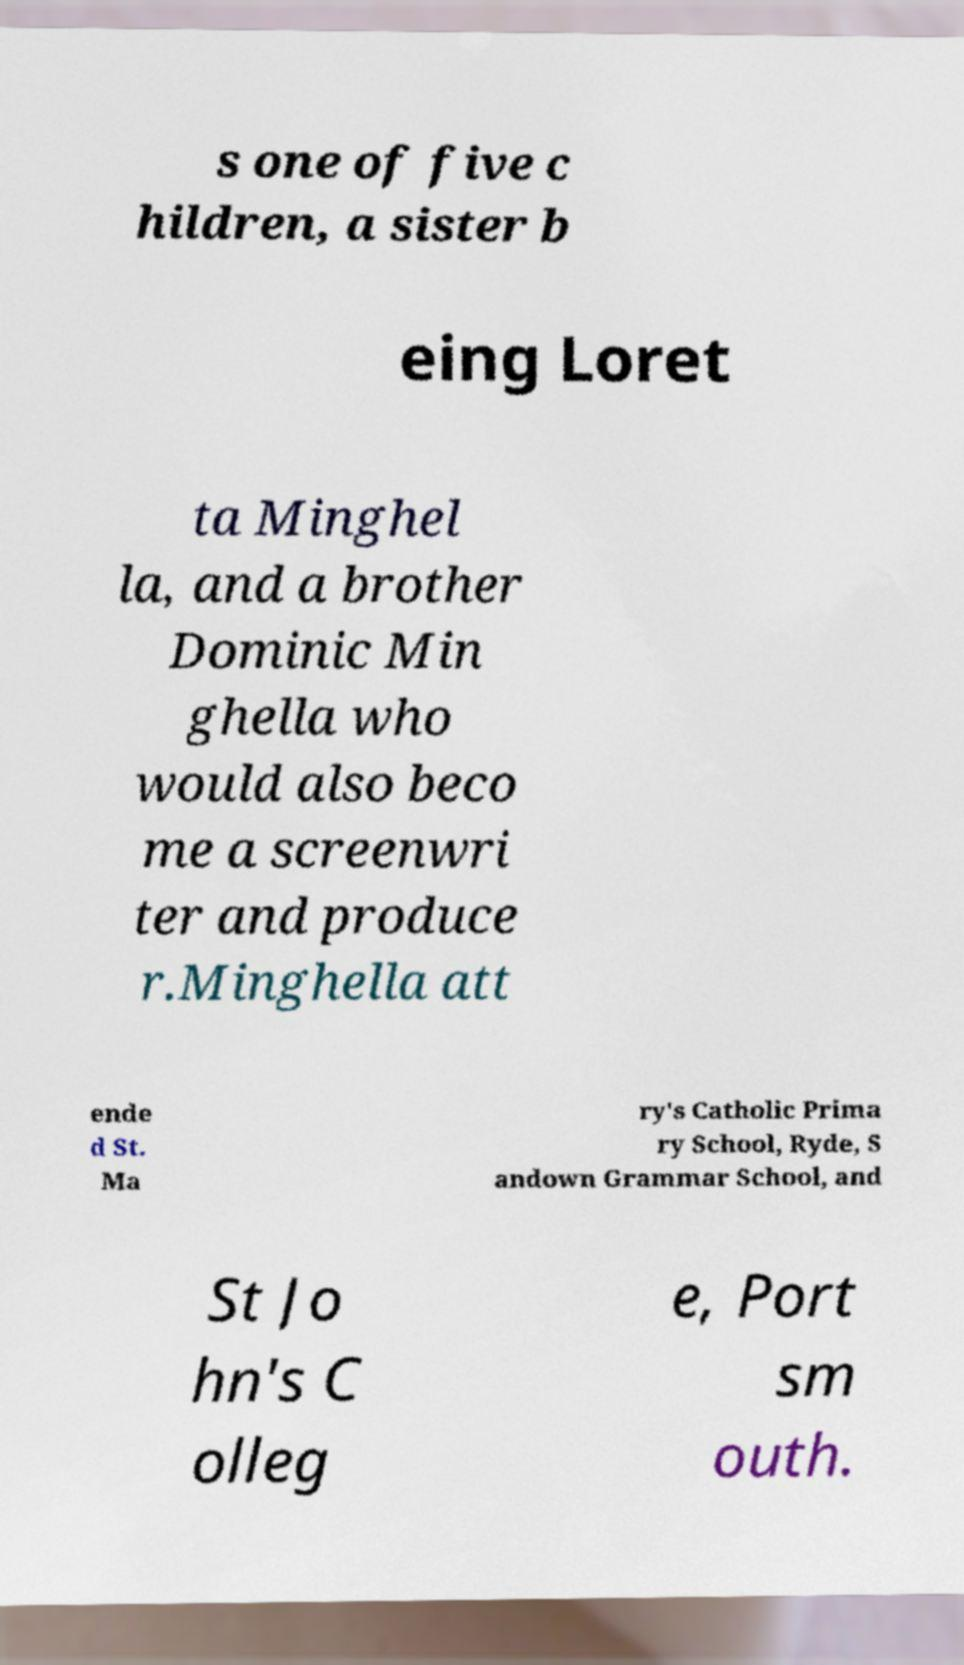Can you accurately transcribe the text from the provided image for me? s one of five c hildren, a sister b eing Loret ta Minghel la, and a brother Dominic Min ghella who would also beco me a screenwri ter and produce r.Minghella att ende d St. Ma ry's Catholic Prima ry School, Ryde, S andown Grammar School, and St Jo hn's C olleg e, Port sm outh. 